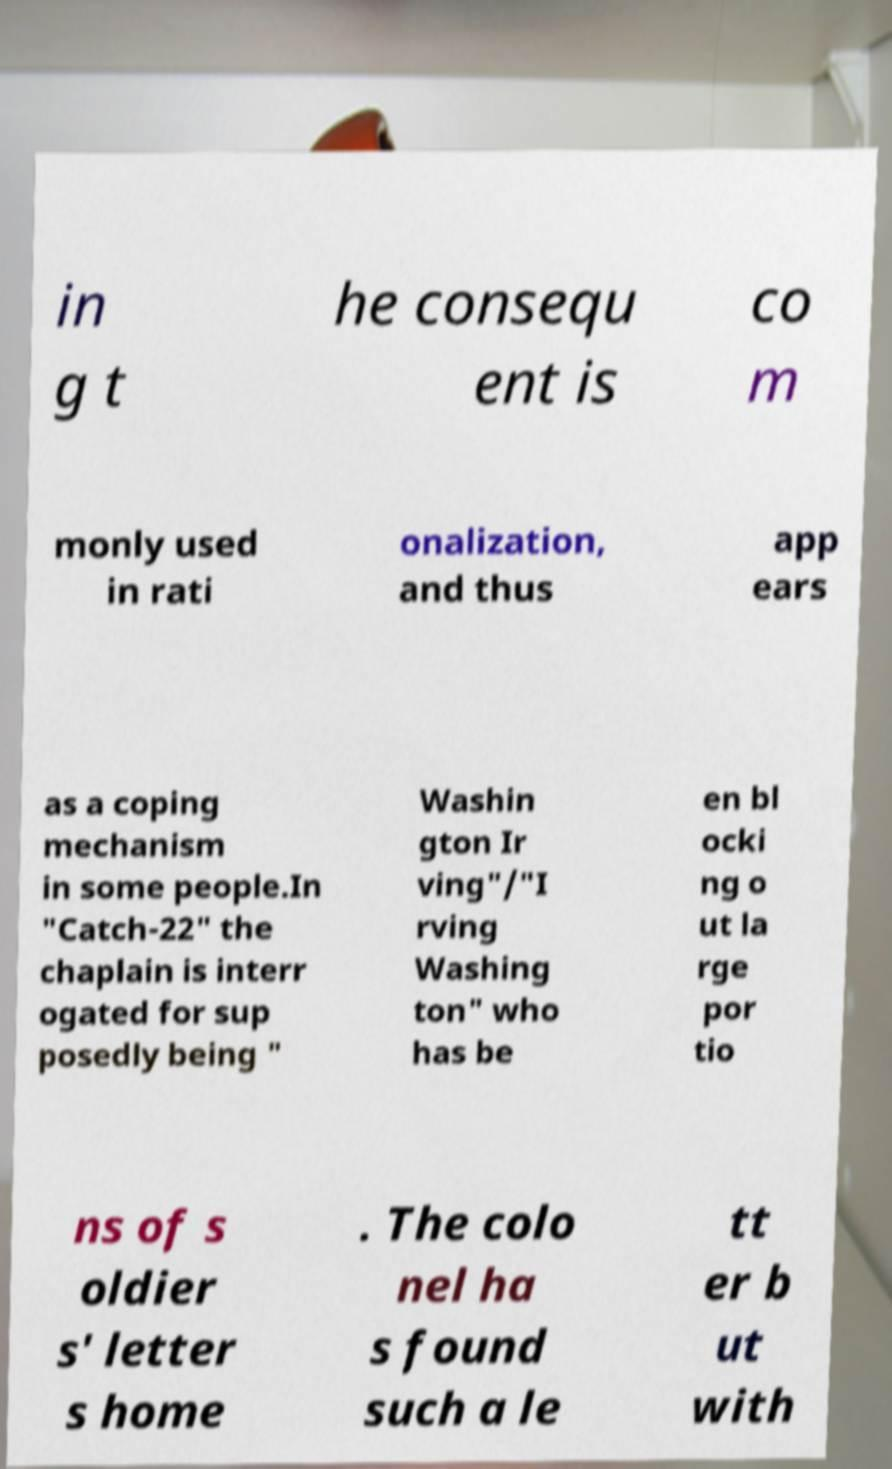Can you accurately transcribe the text from the provided image for me? in g t he consequ ent is co m monly used in rati onalization, and thus app ears as a coping mechanism in some people.In "Catch-22" the chaplain is interr ogated for sup posedly being " Washin gton Ir ving"/"I rving Washing ton" who has be en bl ocki ng o ut la rge por tio ns of s oldier s' letter s home . The colo nel ha s found such a le tt er b ut with 